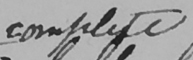What does this handwritten line say? complete 